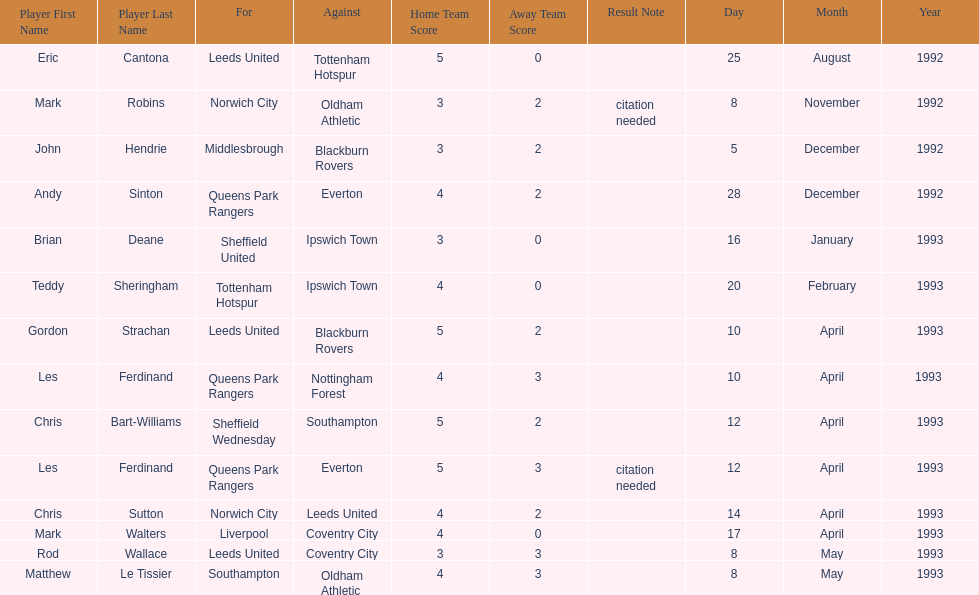Southampton played on may 8th, 1993, who was their opponent? Oldham Athletic. 